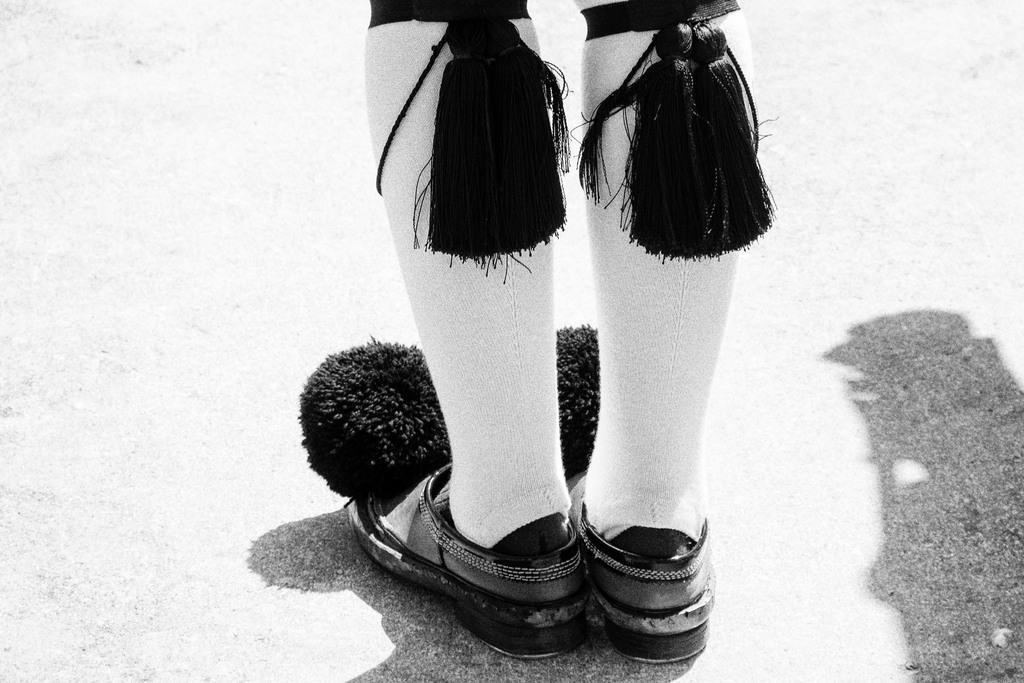Describe this image in one or two sentences. This is a black and white image. In this image we can see the legs of a person wearing shoes. 